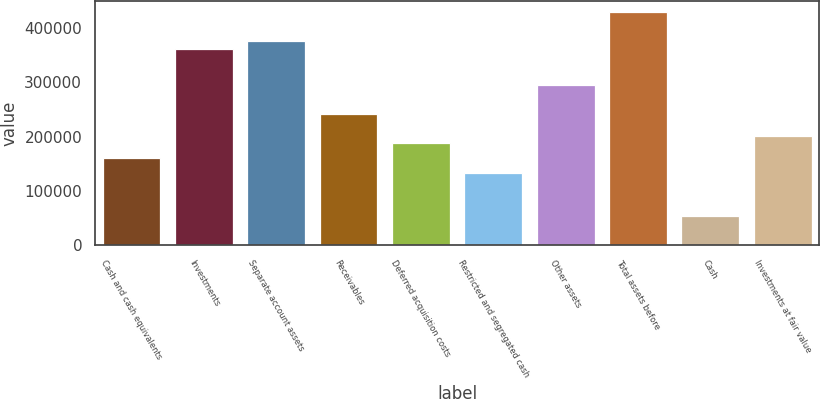<chart> <loc_0><loc_0><loc_500><loc_500><bar_chart><fcel>Cash and cash equivalents<fcel>Investments<fcel>Separate account assets<fcel>Receivables<fcel>Deferred acquisition costs<fcel>Restricted and segregated cash<fcel>Other assets<fcel>Total assets before<fcel>Cash<fcel>Investments at fair value<nl><fcel>160783<fcel>361757<fcel>375155<fcel>241172<fcel>187579<fcel>133986<fcel>294766<fcel>428749<fcel>53596.2<fcel>200978<nl></chart> 